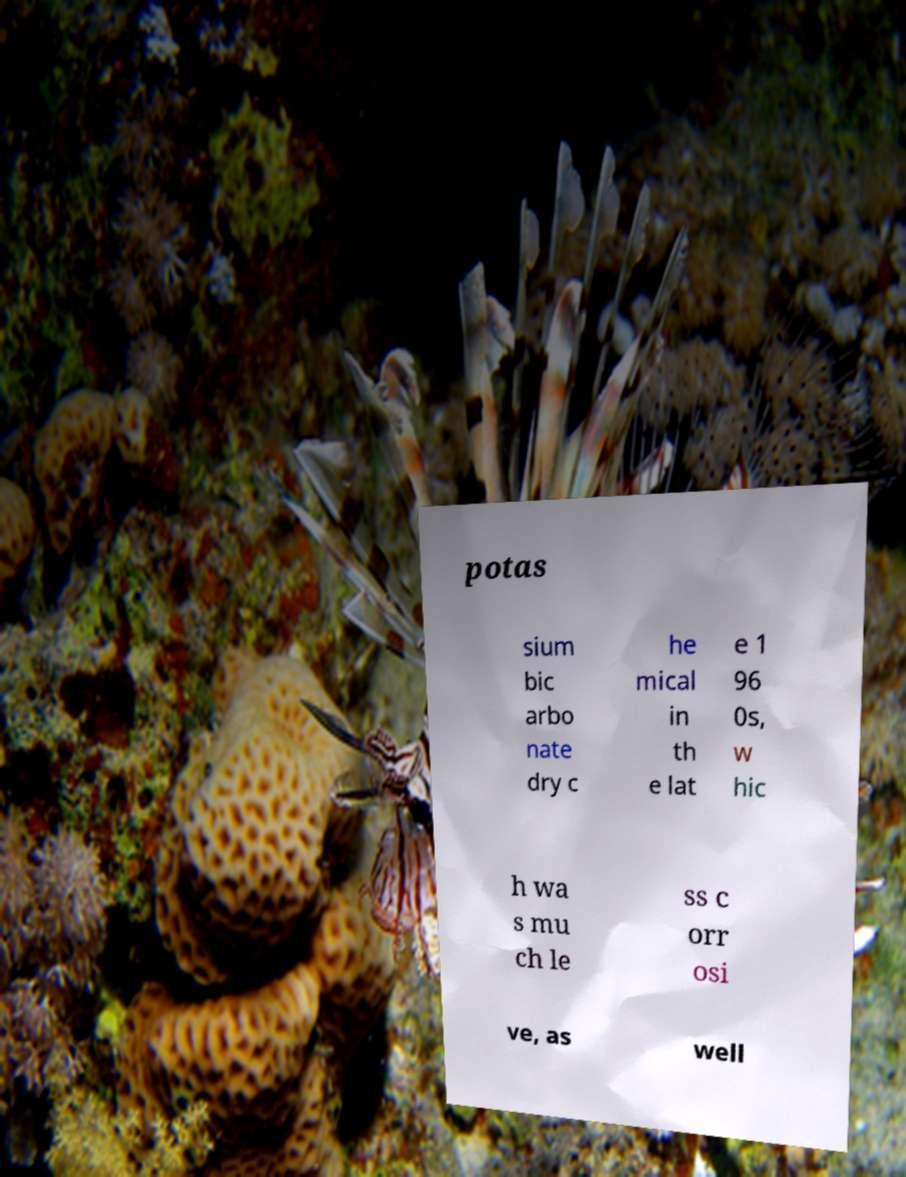Please identify and transcribe the text found in this image. potas sium bic arbo nate dry c he mical in th e lat e 1 96 0s, w hic h wa s mu ch le ss c orr osi ve, as well 